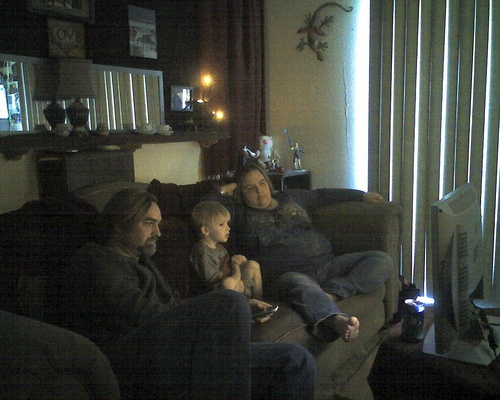Describe the objects in this image and their specific colors. I can see couch in black and gray tones, people in black and gray tones, people in black and gray tones, tv in black, gray, and darkgreen tones, and people in black and gray tones in this image. 